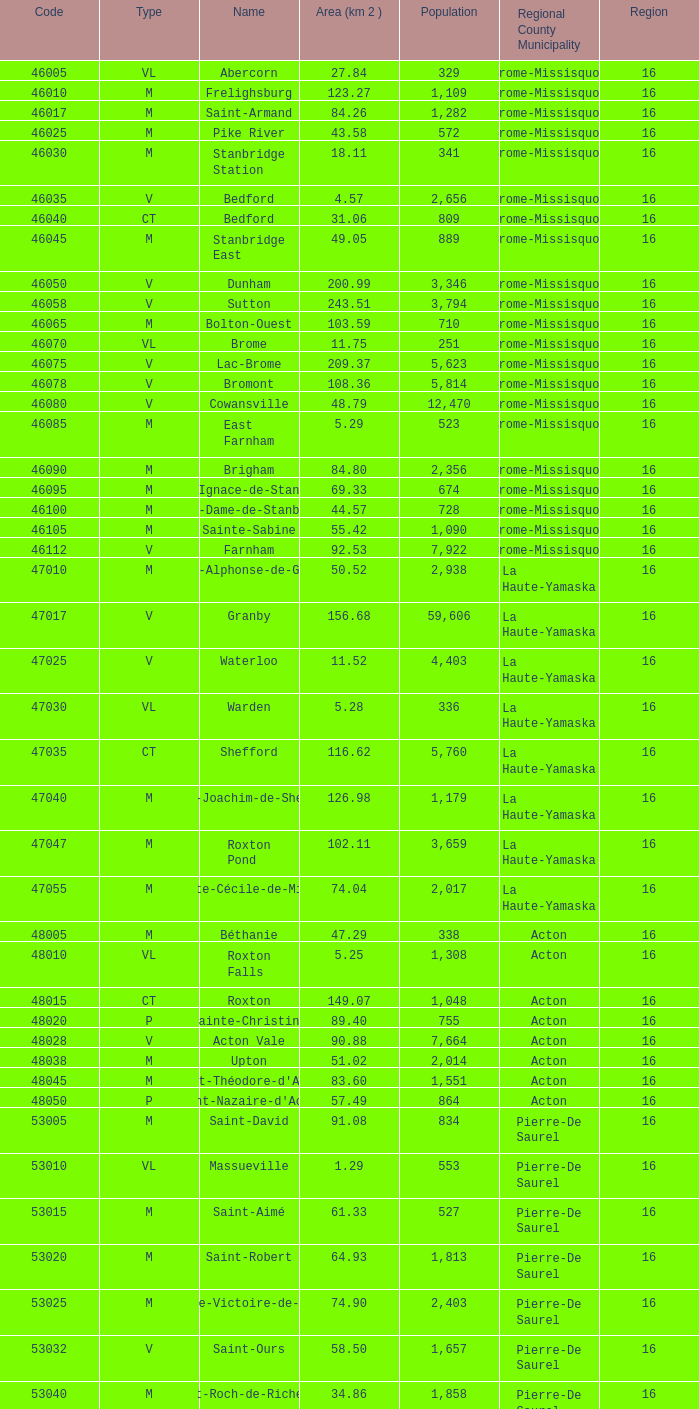With less than 16 districts, cowansville is a brome-missisquoi municipality; what is their population count? None. 